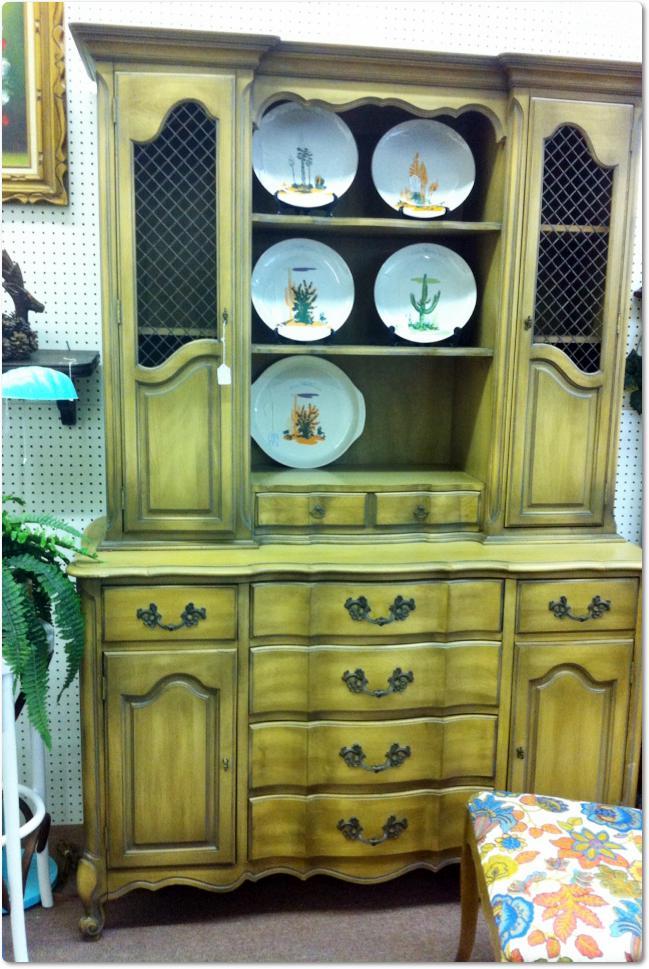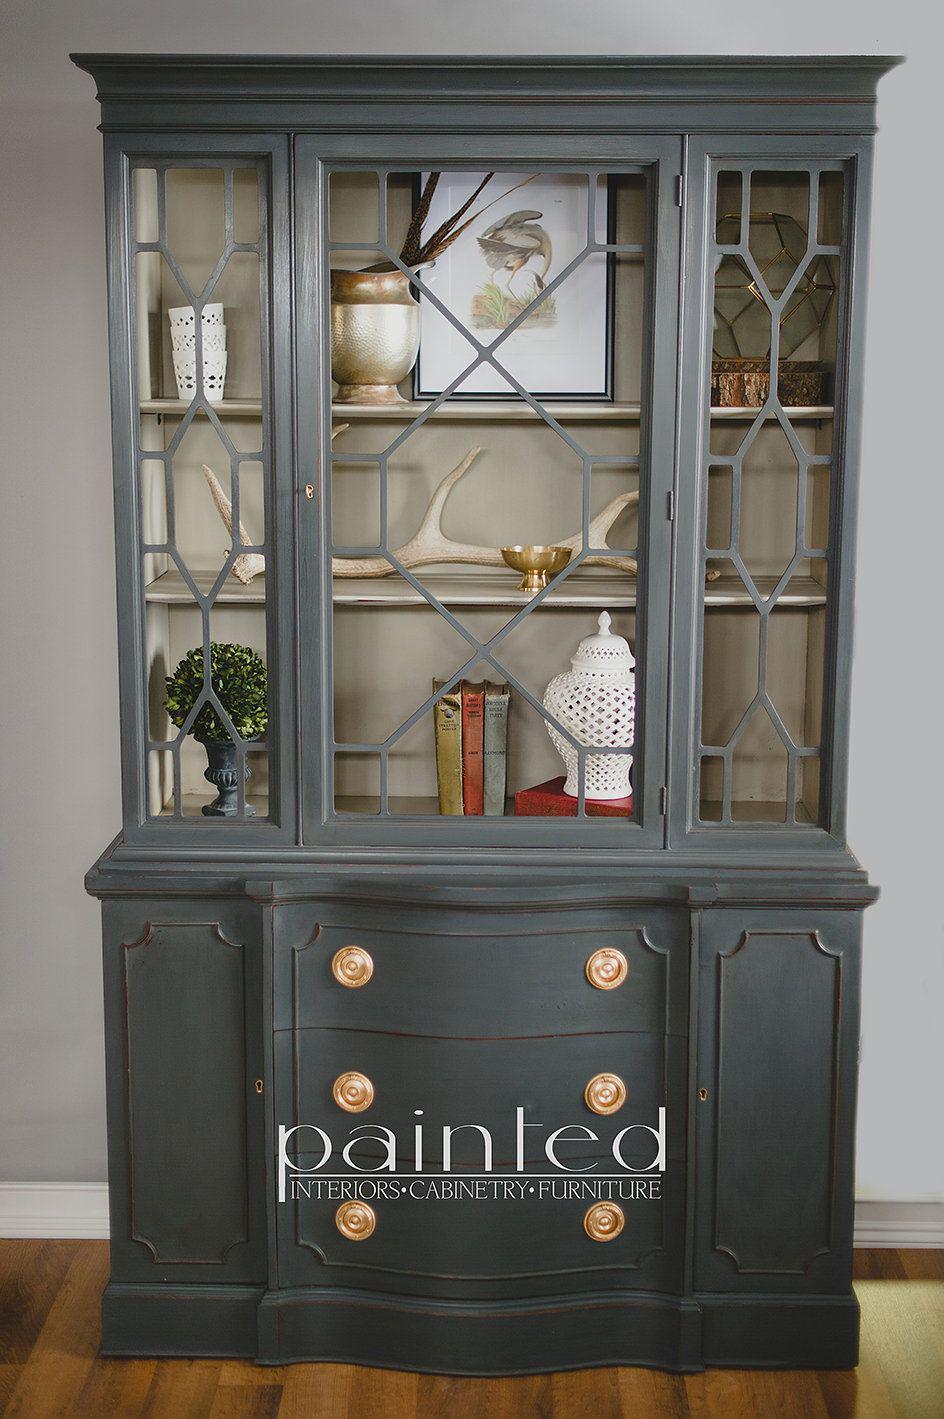The first image is the image on the left, the second image is the image on the right. Examine the images to the left and right. Is the description "There is a plant on the side of the cabinet in the image on the left." accurate? Answer yes or no. Yes. 